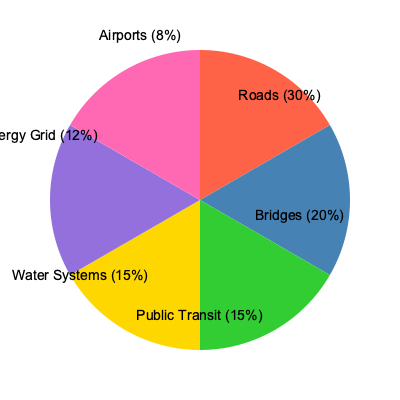As a government public relations officer, you are presenting the allocation of funds for various infrastructure projects. Based on the pie chart, which two sectors combined receive the same percentage of funding as the roads sector alone? To answer this question, we need to follow these steps:

1. Identify the percentage allocated to the roads sector:
   Roads sector receives 30% of the total funding.

2. Find two sectors that, when combined, equal 30%:
   - Public Transit: 15%
   - Water Systems: 15%

3. Verify the calculation:
   15% (Public Transit) + 15% (Water Systems) = 30%

4. Confirm that this matches the roads sector allocation:
   30% (Roads) = 30% (Public Transit + Water Systems)

This comparison allows us to highlight the balanced approach in infrastructure investment, showing that while roads receive significant funding, equal importance is given to other critical sectors like public transit and water systems combined.
Answer: Public Transit and Water Systems 